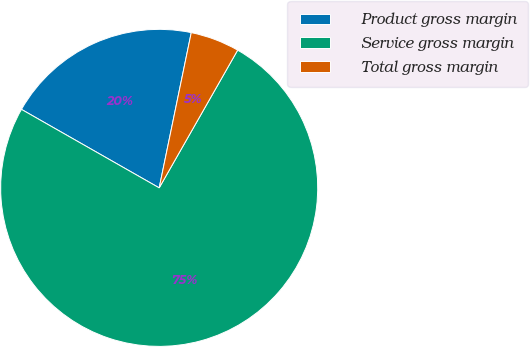<chart> <loc_0><loc_0><loc_500><loc_500><pie_chart><fcel>Product gross margin<fcel>Service gross margin<fcel>Total gross margin<nl><fcel>20.0%<fcel>75.0%<fcel>5.0%<nl></chart> 